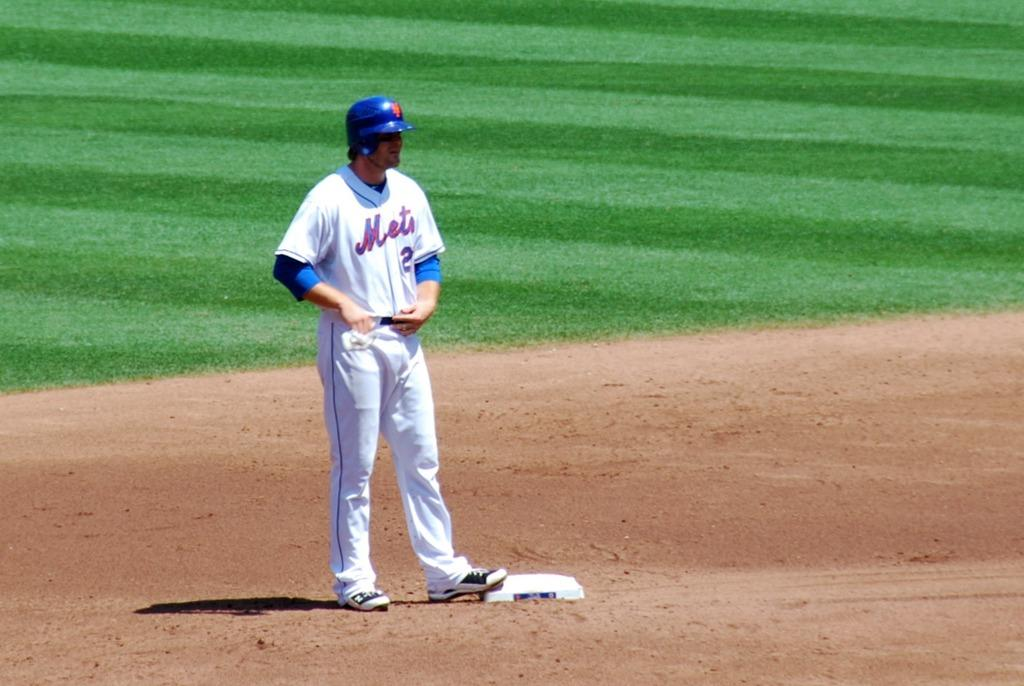Provide a one-sentence caption for the provided image. a player for the Mets is standing on a base, waiting to run. 